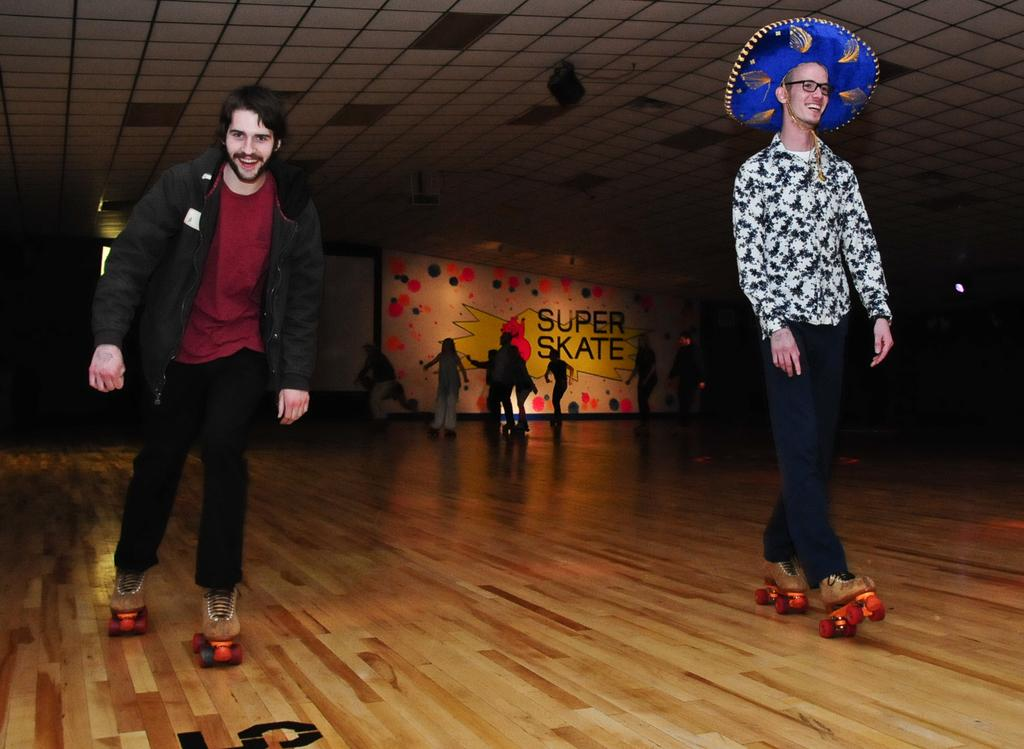What activity are the people in the image engaged in? The people in the image are skating on the floor. What can be seen in the background of the image? There is a board in the background of the image. What can be observed in terms of lighting in the image? There are lights visible in the image. What type of sail can be seen on the people's clothing in the image? There is no sail present on the people's clothing in the image; they are skating. What emotion can be observed on the people's faces in the image? The provided facts do not mention the people's emotions, so it cannot be determined from the image. 